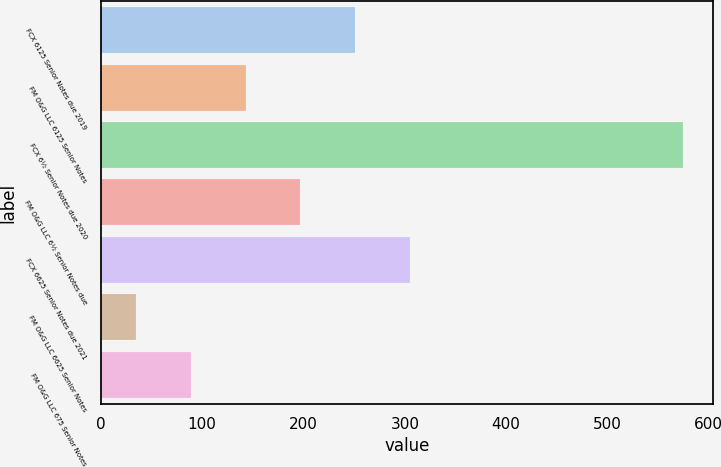<chart> <loc_0><loc_0><loc_500><loc_500><bar_chart><fcel>FCX 6125 Senior Notes due 2019<fcel>FM O&G LLC 6125 Senior Notes<fcel>FCX 6½ Senior Notes due 2020<fcel>FM O&G LLC 6½ Senior Notes due<fcel>FCX 6625 Senior Notes due 2021<fcel>FM O&G LLC 6625 Senior Notes<fcel>FM O&G LLC 675 Senior Notes<nl><fcel>251<fcel>143<fcel>575<fcel>197<fcel>305<fcel>35<fcel>89<nl></chart> 